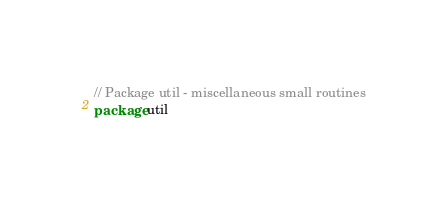<code> <loc_0><loc_0><loc_500><loc_500><_Go_>
// Package util - miscellaneous small routines
package util
</code> 